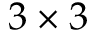<formula> <loc_0><loc_0><loc_500><loc_500>3 \times 3</formula> 